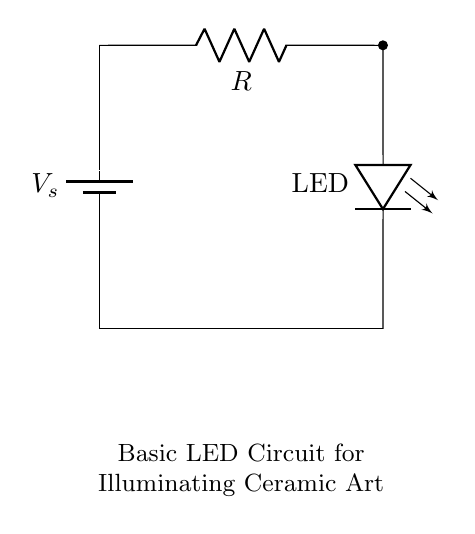What components are in this circuit? The components are a voltage source (battery), a resistor, and an LED. This can be identified by looking at the labels on the circuit, with each element clearly represented and labeled.
Answer: Battery, Resistor, LED What does the resistor do in the circuit? The resistor limits the current flowing through the LED, protecting it from drawing too much current and potentially burning out. It is positioned in series with the LED, directly affecting the current that flows to the LED.
Answer: Limits current What is the purpose of the LED in this circuit? The LED provides illumination, glowing when current passes through it. It is designed to emit light as it allows the current to flow in one direction, completing the circuit with the power supply.
Answer: Provide illumination How many components are in a series in this circuit? There are two components in series: the resistor and the LED. Both elements directly connect, following each other within the same pathway from the positive terminal of the battery to its negative terminal.
Answer: Two What would happen if the resistance value is too low? If the resistance value is too low, the current through the LED would increase significantly, potentially exceeding the LED's maximum rating, leading to damage or failure of the LED. This reasoning follows from Ohm's Law, where lower resistance results in higher current.
Answer: LED may burn out What is the function of the battery in this circuit? The battery serves as the power source, providing the necessary voltage to drive the current through the circuit. It is essential to energize the circuit components and allow them to function correctly.
Answer: Power source 